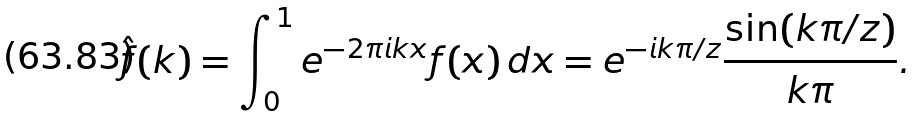Convert formula to latex. <formula><loc_0><loc_0><loc_500><loc_500>\hat { f } ( k ) = \int _ { 0 } ^ { 1 } e ^ { - 2 \pi i k x } f ( x ) \, d x = e ^ { - i k \pi / z } \frac { \sin ( k \pi / z ) } { k \pi } .</formula> 